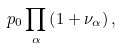<formula> <loc_0><loc_0><loc_500><loc_500>p _ { 0 } \prod _ { \alpha } \left ( 1 + \nu _ { \alpha } \right ) ,</formula> 